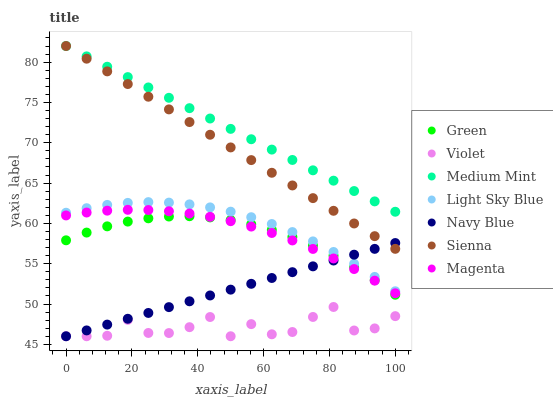Does Violet have the minimum area under the curve?
Answer yes or no. Yes. Does Medium Mint have the maximum area under the curve?
Answer yes or no. Yes. Does Navy Blue have the minimum area under the curve?
Answer yes or no. No. Does Navy Blue have the maximum area under the curve?
Answer yes or no. No. Is Sienna the smoothest?
Answer yes or no. Yes. Is Violet the roughest?
Answer yes or no. Yes. Is Navy Blue the smoothest?
Answer yes or no. No. Is Navy Blue the roughest?
Answer yes or no. No. Does Navy Blue have the lowest value?
Answer yes or no. Yes. Does Sienna have the lowest value?
Answer yes or no. No. Does Sienna have the highest value?
Answer yes or no. Yes. Does Navy Blue have the highest value?
Answer yes or no. No. Is Violet less than Medium Mint?
Answer yes or no. Yes. Is Light Sky Blue greater than Magenta?
Answer yes or no. Yes. Does Green intersect Magenta?
Answer yes or no. Yes. Is Green less than Magenta?
Answer yes or no. No. Is Green greater than Magenta?
Answer yes or no. No. Does Violet intersect Medium Mint?
Answer yes or no. No. 